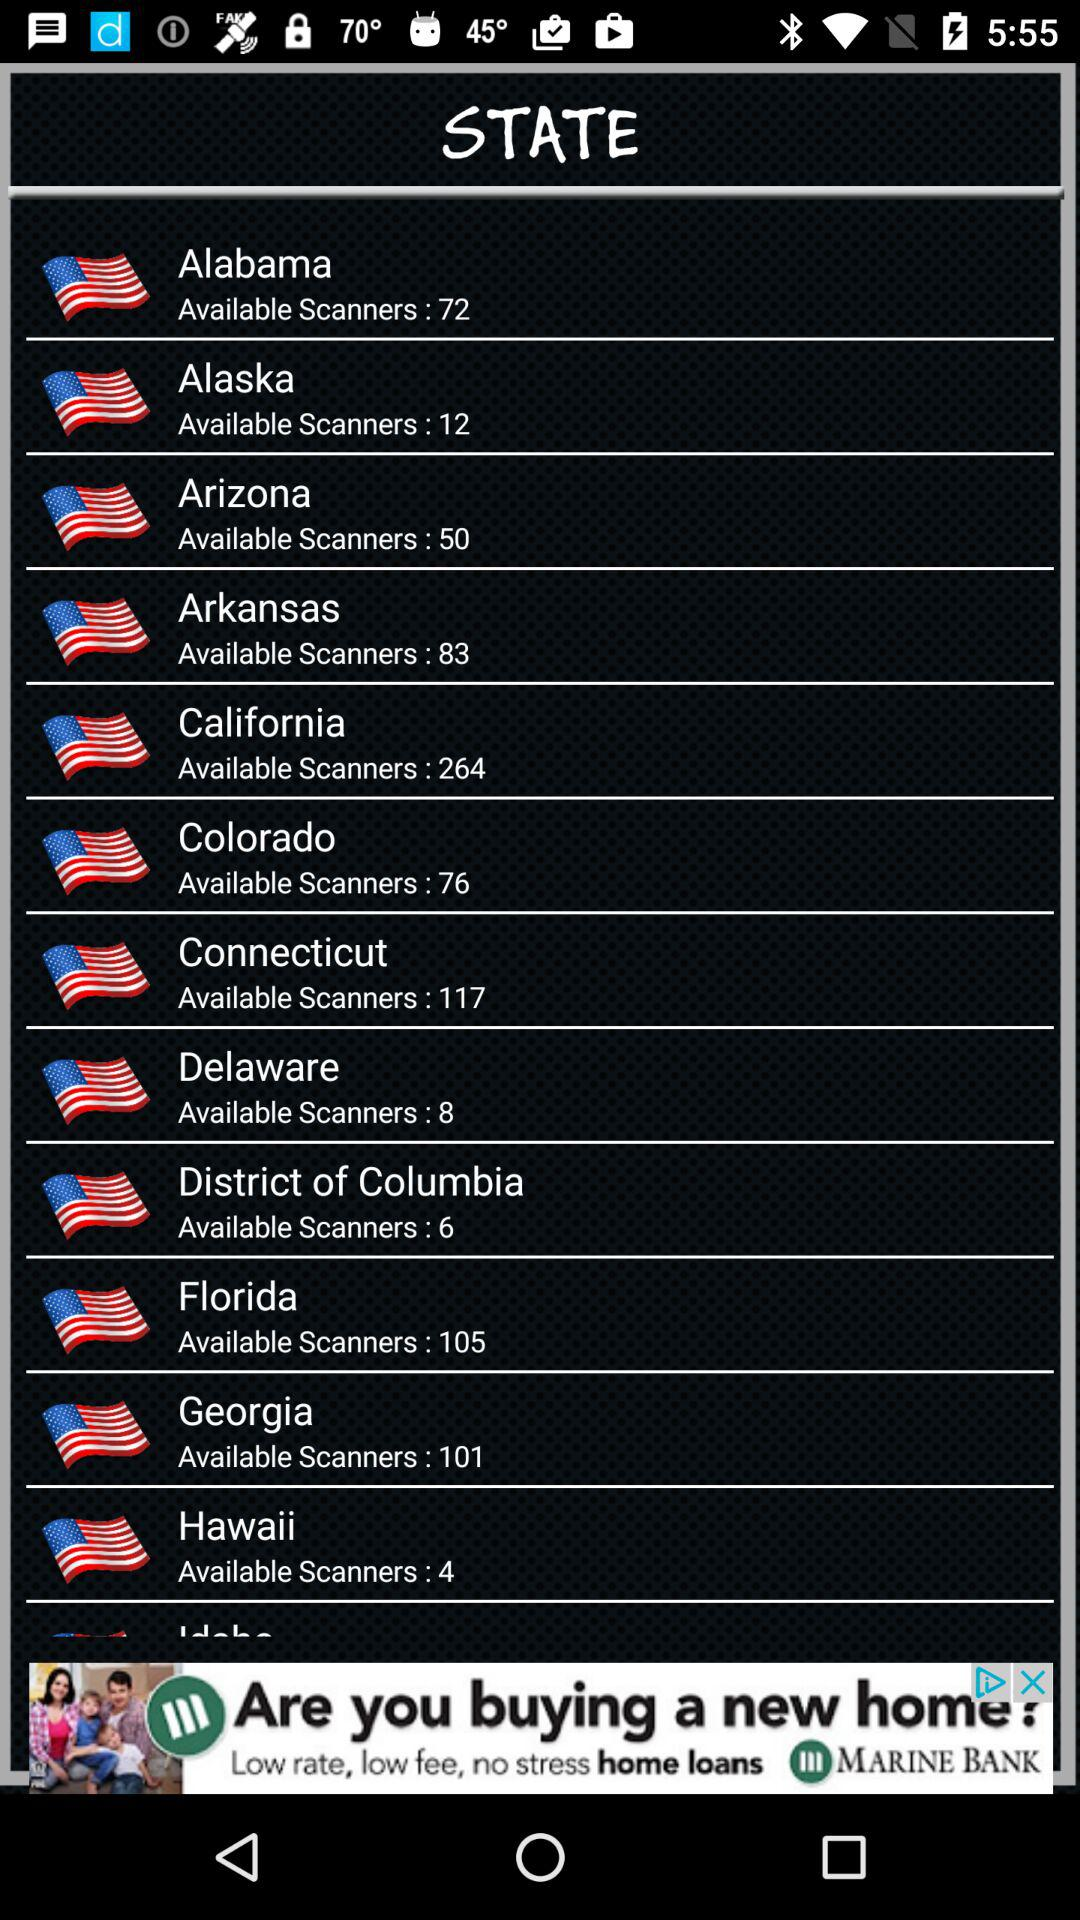Which state has the most available scanners?
Answer the question using a single word or phrase. California 